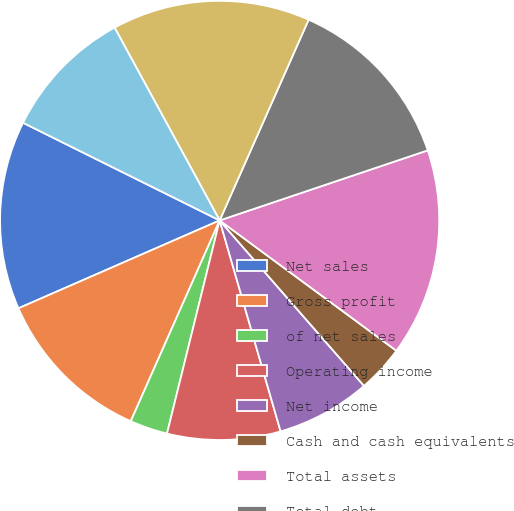Convert chart. <chart><loc_0><loc_0><loc_500><loc_500><pie_chart><fcel>Net sales<fcel>Gross profit<fcel>of net sales<fcel>Operating income<fcel>Net income<fcel>Cash and cash equivalents<fcel>Total assets<fcel>Total debt<fcel>Total shareholders' equity<fcel>Net cash provided by operating<nl><fcel>13.89%<fcel>11.81%<fcel>2.78%<fcel>8.33%<fcel>6.94%<fcel>3.47%<fcel>15.28%<fcel>13.19%<fcel>14.58%<fcel>9.72%<nl></chart> 